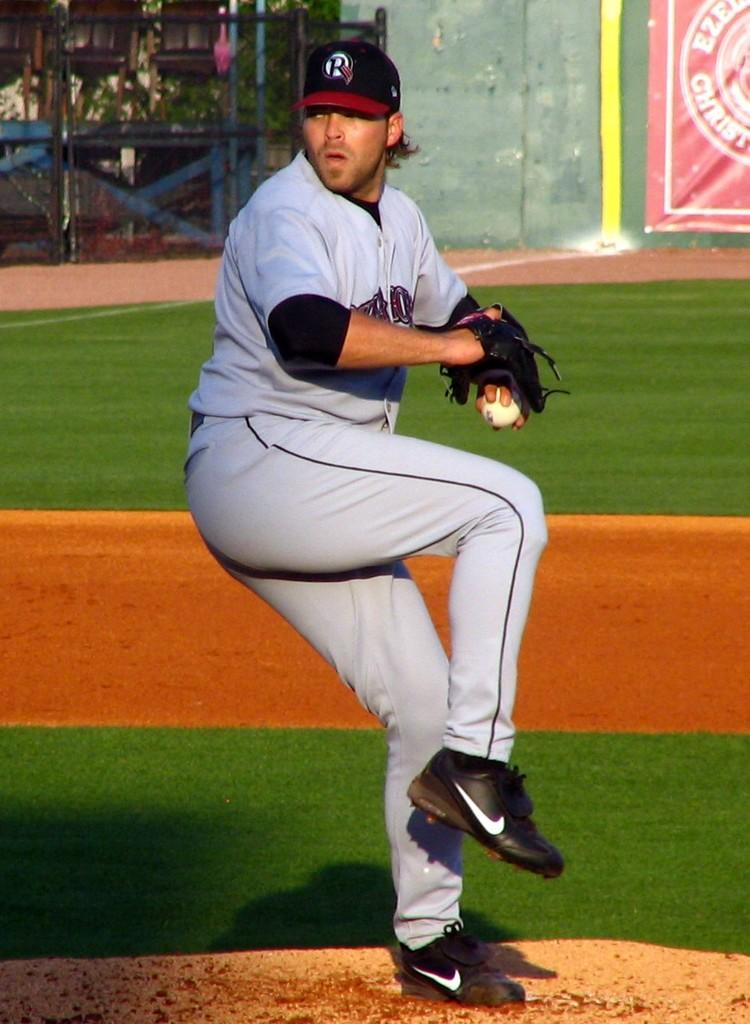<image>
Render a clear and concise summary of the photo. the pitcher is wearing a hat with letter R on it 